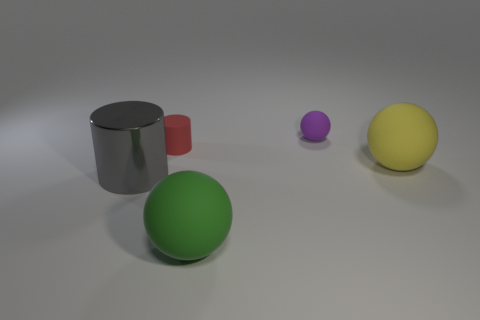Add 3 green matte things. How many objects exist? 8 Subtract all cylinders. How many objects are left? 3 Subtract all big gray cylinders. Subtract all gray matte balls. How many objects are left? 4 Add 3 big spheres. How many big spheres are left? 5 Add 1 big cyan things. How many big cyan things exist? 1 Subtract 0 blue cylinders. How many objects are left? 5 